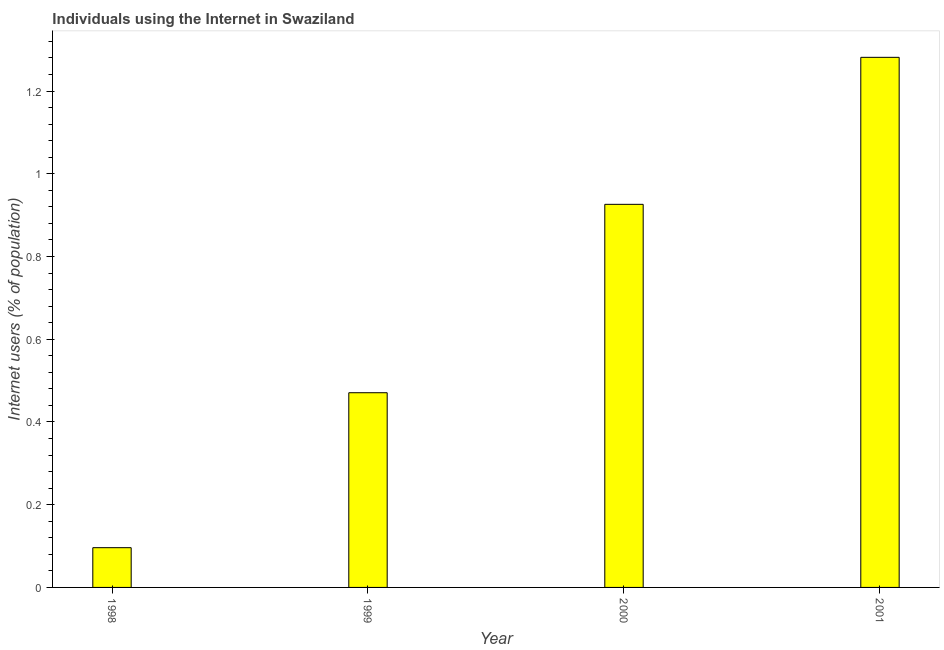Does the graph contain any zero values?
Give a very brief answer. No. What is the title of the graph?
Your response must be concise. Individuals using the Internet in Swaziland. What is the label or title of the Y-axis?
Give a very brief answer. Internet users (% of population). What is the number of internet users in 1998?
Make the answer very short. 0.1. Across all years, what is the maximum number of internet users?
Ensure brevity in your answer.  1.28. Across all years, what is the minimum number of internet users?
Your answer should be very brief. 0.1. In which year was the number of internet users maximum?
Offer a very short reply. 2001. What is the sum of the number of internet users?
Offer a terse response. 2.77. What is the difference between the number of internet users in 2000 and 2001?
Your answer should be compact. -0.35. What is the average number of internet users per year?
Keep it short and to the point. 0.69. What is the median number of internet users?
Provide a short and direct response. 0.7. Do a majority of the years between 1999 and 2001 (inclusive) have number of internet users greater than 0.84 %?
Keep it short and to the point. Yes. What is the ratio of the number of internet users in 1999 to that in 2000?
Offer a terse response. 0.51. Is the difference between the number of internet users in 1999 and 2001 greater than the difference between any two years?
Provide a succinct answer. No. What is the difference between the highest and the second highest number of internet users?
Ensure brevity in your answer.  0.35. What is the difference between the highest and the lowest number of internet users?
Provide a short and direct response. 1.19. In how many years, is the number of internet users greater than the average number of internet users taken over all years?
Offer a terse response. 2. How many bars are there?
Your answer should be compact. 4. Are all the bars in the graph horizontal?
Provide a short and direct response. No. What is the difference between two consecutive major ticks on the Y-axis?
Your answer should be very brief. 0.2. What is the Internet users (% of population) in 1998?
Provide a succinct answer. 0.1. What is the Internet users (% of population) of 1999?
Ensure brevity in your answer.  0.47. What is the Internet users (% of population) of 2000?
Make the answer very short. 0.93. What is the Internet users (% of population) in 2001?
Provide a succinct answer. 1.28. What is the difference between the Internet users (% of population) in 1998 and 1999?
Ensure brevity in your answer.  -0.37. What is the difference between the Internet users (% of population) in 1998 and 2000?
Your answer should be compact. -0.83. What is the difference between the Internet users (% of population) in 1998 and 2001?
Offer a very short reply. -1.19. What is the difference between the Internet users (% of population) in 1999 and 2000?
Make the answer very short. -0.46. What is the difference between the Internet users (% of population) in 1999 and 2001?
Make the answer very short. -0.81. What is the difference between the Internet users (% of population) in 2000 and 2001?
Keep it short and to the point. -0.36. What is the ratio of the Internet users (% of population) in 1998 to that in 1999?
Give a very brief answer. 0.2. What is the ratio of the Internet users (% of population) in 1998 to that in 2000?
Provide a short and direct response. 0.1. What is the ratio of the Internet users (% of population) in 1998 to that in 2001?
Your answer should be very brief. 0.07. What is the ratio of the Internet users (% of population) in 1999 to that in 2000?
Your response must be concise. 0.51. What is the ratio of the Internet users (% of population) in 1999 to that in 2001?
Your answer should be very brief. 0.37. What is the ratio of the Internet users (% of population) in 2000 to that in 2001?
Offer a terse response. 0.72. 